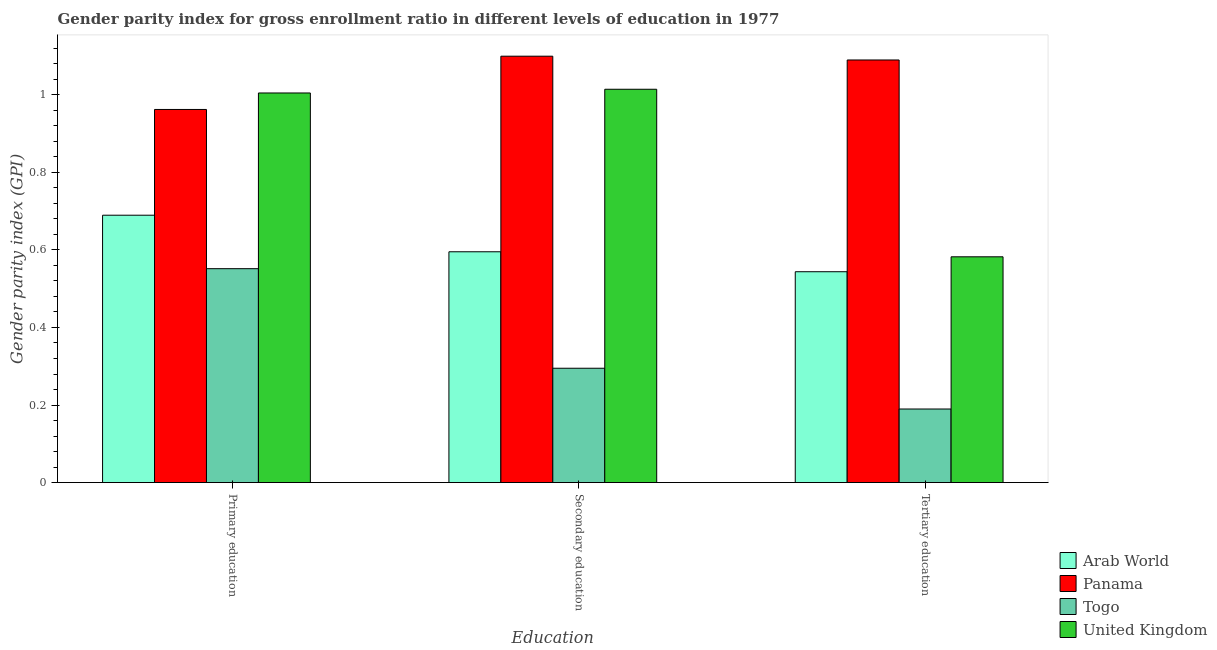Are the number of bars per tick equal to the number of legend labels?
Provide a short and direct response. Yes. How many bars are there on the 2nd tick from the right?
Ensure brevity in your answer.  4. What is the label of the 3rd group of bars from the left?
Keep it short and to the point. Tertiary education. What is the gender parity index in primary education in Arab World?
Make the answer very short. 0.69. Across all countries, what is the maximum gender parity index in tertiary education?
Make the answer very short. 1.09. Across all countries, what is the minimum gender parity index in secondary education?
Make the answer very short. 0.29. In which country was the gender parity index in primary education maximum?
Offer a very short reply. United Kingdom. In which country was the gender parity index in tertiary education minimum?
Provide a succinct answer. Togo. What is the total gender parity index in tertiary education in the graph?
Your response must be concise. 2.41. What is the difference between the gender parity index in secondary education in United Kingdom and that in Togo?
Your response must be concise. 0.72. What is the difference between the gender parity index in tertiary education in Panama and the gender parity index in primary education in Togo?
Offer a very short reply. 0.54. What is the average gender parity index in secondary education per country?
Keep it short and to the point. 0.75. What is the difference between the gender parity index in primary education and gender parity index in tertiary education in Togo?
Provide a succinct answer. 0.36. In how many countries, is the gender parity index in primary education greater than 1 ?
Make the answer very short. 1. What is the ratio of the gender parity index in secondary education in Panama to that in Togo?
Your answer should be very brief. 3.73. Is the gender parity index in primary education in United Kingdom less than that in Panama?
Keep it short and to the point. No. What is the difference between the highest and the second highest gender parity index in secondary education?
Give a very brief answer. 0.09. What is the difference between the highest and the lowest gender parity index in secondary education?
Your answer should be compact. 0.8. Is the sum of the gender parity index in secondary education in Togo and Arab World greater than the maximum gender parity index in primary education across all countries?
Provide a short and direct response. No. What does the 2nd bar from the left in Primary education represents?
Provide a succinct answer. Panama. What does the 3rd bar from the right in Secondary education represents?
Provide a succinct answer. Panama. Is it the case that in every country, the sum of the gender parity index in primary education and gender parity index in secondary education is greater than the gender parity index in tertiary education?
Your answer should be very brief. Yes. How many bars are there?
Your response must be concise. 12. Are all the bars in the graph horizontal?
Provide a succinct answer. No. Are the values on the major ticks of Y-axis written in scientific E-notation?
Give a very brief answer. No. Does the graph contain any zero values?
Your answer should be very brief. No. Does the graph contain grids?
Ensure brevity in your answer.  No. Where does the legend appear in the graph?
Your answer should be compact. Bottom right. How many legend labels are there?
Provide a short and direct response. 4. What is the title of the graph?
Give a very brief answer. Gender parity index for gross enrollment ratio in different levels of education in 1977. What is the label or title of the X-axis?
Offer a terse response. Education. What is the label or title of the Y-axis?
Keep it short and to the point. Gender parity index (GPI). What is the Gender parity index (GPI) in Arab World in Primary education?
Offer a very short reply. 0.69. What is the Gender parity index (GPI) in Panama in Primary education?
Offer a terse response. 0.96. What is the Gender parity index (GPI) in Togo in Primary education?
Provide a succinct answer. 0.55. What is the Gender parity index (GPI) of United Kingdom in Primary education?
Offer a very short reply. 1. What is the Gender parity index (GPI) in Arab World in Secondary education?
Your answer should be very brief. 0.6. What is the Gender parity index (GPI) in Panama in Secondary education?
Your response must be concise. 1.1. What is the Gender parity index (GPI) of Togo in Secondary education?
Offer a terse response. 0.29. What is the Gender parity index (GPI) in United Kingdom in Secondary education?
Your answer should be compact. 1.01. What is the Gender parity index (GPI) of Arab World in Tertiary education?
Provide a succinct answer. 0.54. What is the Gender parity index (GPI) in Panama in Tertiary education?
Your response must be concise. 1.09. What is the Gender parity index (GPI) of Togo in Tertiary education?
Make the answer very short. 0.19. What is the Gender parity index (GPI) in United Kingdom in Tertiary education?
Offer a terse response. 0.58. Across all Education, what is the maximum Gender parity index (GPI) of Arab World?
Provide a succinct answer. 0.69. Across all Education, what is the maximum Gender parity index (GPI) in Panama?
Provide a short and direct response. 1.1. Across all Education, what is the maximum Gender parity index (GPI) in Togo?
Ensure brevity in your answer.  0.55. Across all Education, what is the maximum Gender parity index (GPI) of United Kingdom?
Give a very brief answer. 1.01. Across all Education, what is the minimum Gender parity index (GPI) of Arab World?
Ensure brevity in your answer.  0.54. Across all Education, what is the minimum Gender parity index (GPI) of Panama?
Provide a short and direct response. 0.96. Across all Education, what is the minimum Gender parity index (GPI) of Togo?
Offer a very short reply. 0.19. Across all Education, what is the minimum Gender parity index (GPI) of United Kingdom?
Provide a succinct answer. 0.58. What is the total Gender parity index (GPI) in Arab World in the graph?
Ensure brevity in your answer.  1.83. What is the total Gender parity index (GPI) of Panama in the graph?
Ensure brevity in your answer.  3.15. What is the total Gender parity index (GPI) of Togo in the graph?
Offer a very short reply. 1.04. What is the total Gender parity index (GPI) of United Kingdom in the graph?
Your response must be concise. 2.6. What is the difference between the Gender parity index (GPI) in Arab World in Primary education and that in Secondary education?
Give a very brief answer. 0.09. What is the difference between the Gender parity index (GPI) of Panama in Primary education and that in Secondary education?
Keep it short and to the point. -0.14. What is the difference between the Gender parity index (GPI) in Togo in Primary education and that in Secondary education?
Your answer should be compact. 0.26. What is the difference between the Gender parity index (GPI) in United Kingdom in Primary education and that in Secondary education?
Give a very brief answer. -0.01. What is the difference between the Gender parity index (GPI) in Arab World in Primary education and that in Tertiary education?
Provide a short and direct response. 0.15. What is the difference between the Gender parity index (GPI) of Panama in Primary education and that in Tertiary education?
Provide a succinct answer. -0.13. What is the difference between the Gender parity index (GPI) in Togo in Primary education and that in Tertiary education?
Keep it short and to the point. 0.36. What is the difference between the Gender parity index (GPI) of United Kingdom in Primary education and that in Tertiary education?
Your answer should be very brief. 0.42. What is the difference between the Gender parity index (GPI) of Arab World in Secondary education and that in Tertiary education?
Your response must be concise. 0.05. What is the difference between the Gender parity index (GPI) in Panama in Secondary education and that in Tertiary education?
Ensure brevity in your answer.  0.01. What is the difference between the Gender parity index (GPI) of Togo in Secondary education and that in Tertiary education?
Ensure brevity in your answer.  0.11. What is the difference between the Gender parity index (GPI) in United Kingdom in Secondary education and that in Tertiary education?
Make the answer very short. 0.43. What is the difference between the Gender parity index (GPI) in Arab World in Primary education and the Gender parity index (GPI) in Panama in Secondary education?
Give a very brief answer. -0.41. What is the difference between the Gender parity index (GPI) in Arab World in Primary education and the Gender parity index (GPI) in Togo in Secondary education?
Offer a terse response. 0.39. What is the difference between the Gender parity index (GPI) of Arab World in Primary education and the Gender parity index (GPI) of United Kingdom in Secondary education?
Your response must be concise. -0.32. What is the difference between the Gender parity index (GPI) of Panama in Primary education and the Gender parity index (GPI) of Togo in Secondary education?
Provide a short and direct response. 0.67. What is the difference between the Gender parity index (GPI) of Panama in Primary education and the Gender parity index (GPI) of United Kingdom in Secondary education?
Offer a very short reply. -0.05. What is the difference between the Gender parity index (GPI) in Togo in Primary education and the Gender parity index (GPI) in United Kingdom in Secondary education?
Provide a short and direct response. -0.46. What is the difference between the Gender parity index (GPI) of Arab World in Primary education and the Gender parity index (GPI) of Panama in Tertiary education?
Offer a terse response. -0.4. What is the difference between the Gender parity index (GPI) of Arab World in Primary education and the Gender parity index (GPI) of Togo in Tertiary education?
Your response must be concise. 0.5. What is the difference between the Gender parity index (GPI) of Arab World in Primary education and the Gender parity index (GPI) of United Kingdom in Tertiary education?
Provide a succinct answer. 0.11. What is the difference between the Gender parity index (GPI) in Panama in Primary education and the Gender parity index (GPI) in Togo in Tertiary education?
Provide a short and direct response. 0.77. What is the difference between the Gender parity index (GPI) in Panama in Primary education and the Gender parity index (GPI) in United Kingdom in Tertiary education?
Your answer should be compact. 0.38. What is the difference between the Gender parity index (GPI) in Togo in Primary education and the Gender parity index (GPI) in United Kingdom in Tertiary education?
Provide a succinct answer. -0.03. What is the difference between the Gender parity index (GPI) of Arab World in Secondary education and the Gender parity index (GPI) of Panama in Tertiary education?
Make the answer very short. -0.49. What is the difference between the Gender parity index (GPI) of Arab World in Secondary education and the Gender parity index (GPI) of Togo in Tertiary education?
Keep it short and to the point. 0.41. What is the difference between the Gender parity index (GPI) of Arab World in Secondary education and the Gender parity index (GPI) of United Kingdom in Tertiary education?
Give a very brief answer. 0.01. What is the difference between the Gender parity index (GPI) in Panama in Secondary education and the Gender parity index (GPI) in Togo in Tertiary education?
Your answer should be very brief. 0.91. What is the difference between the Gender parity index (GPI) in Panama in Secondary education and the Gender parity index (GPI) in United Kingdom in Tertiary education?
Your answer should be very brief. 0.52. What is the difference between the Gender parity index (GPI) of Togo in Secondary education and the Gender parity index (GPI) of United Kingdom in Tertiary education?
Your answer should be compact. -0.29. What is the average Gender parity index (GPI) of Arab World per Education?
Provide a short and direct response. 0.61. What is the average Gender parity index (GPI) in Panama per Education?
Provide a succinct answer. 1.05. What is the average Gender parity index (GPI) in Togo per Education?
Make the answer very short. 0.35. What is the average Gender parity index (GPI) of United Kingdom per Education?
Keep it short and to the point. 0.87. What is the difference between the Gender parity index (GPI) in Arab World and Gender parity index (GPI) in Panama in Primary education?
Ensure brevity in your answer.  -0.27. What is the difference between the Gender parity index (GPI) in Arab World and Gender parity index (GPI) in Togo in Primary education?
Provide a short and direct response. 0.14. What is the difference between the Gender parity index (GPI) of Arab World and Gender parity index (GPI) of United Kingdom in Primary education?
Your answer should be very brief. -0.32. What is the difference between the Gender parity index (GPI) of Panama and Gender parity index (GPI) of Togo in Primary education?
Give a very brief answer. 0.41. What is the difference between the Gender parity index (GPI) in Panama and Gender parity index (GPI) in United Kingdom in Primary education?
Offer a very short reply. -0.04. What is the difference between the Gender parity index (GPI) of Togo and Gender parity index (GPI) of United Kingdom in Primary education?
Provide a short and direct response. -0.45. What is the difference between the Gender parity index (GPI) of Arab World and Gender parity index (GPI) of Panama in Secondary education?
Offer a very short reply. -0.5. What is the difference between the Gender parity index (GPI) in Arab World and Gender parity index (GPI) in Togo in Secondary education?
Provide a succinct answer. 0.3. What is the difference between the Gender parity index (GPI) of Arab World and Gender parity index (GPI) of United Kingdom in Secondary education?
Your answer should be very brief. -0.42. What is the difference between the Gender parity index (GPI) of Panama and Gender parity index (GPI) of Togo in Secondary education?
Offer a very short reply. 0.8. What is the difference between the Gender parity index (GPI) in Panama and Gender parity index (GPI) in United Kingdom in Secondary education?
Offer a terse response. 0.09. What is the difference between the Gender parity index (GPI) of Togo and Gender parity index (GPI) of United Kingdom in Secondary education?
Your answer should be compact. -0.72. What is the difference between the Gender parity index (GPI) of Arab World and Gender parity index (GPI) of Panama in Tertiary education?
Your response must be concise. -0.55. What is the difference between the Gender parity index (GPI) of Arab World and Gender parity index (GPI) of Togo in Tertiary education?
Your answer should be compact. 0.35. What is the difference between the Gender parity index (GPI) in Arab World and Gender parity index (GPI) in United Kingdom in Tertiary education?
Offer a very short reply. -0.04. What is the difference between the Gender parity index (GPI) in Panama and Gender parity index (GPI) in Togo in Tertiary education?
Ensure brevity in your answer.  0.9. What is the difference between the Gender parity index (GPI) of Panama and Gender parity index (GPI) of United Kingdom in Tertiary education?
Your answer should be compact. 0.51. What is the difference between the Gender parity index (GPI) of Togo and Gender parity index (GPI) of United Kingdom in Tertiary education?
Offer a very short reply. -0.39. What is the ratio of the Gender parity index (GPI) in Arab World in Primary education to that in Secondary education?
Your answer should be very brief. 1.16. What is the ratio of the Gender parity index (GPI) in Panama in Primary education to that in Secondary education?
Your answer should be compact. 0.88. What is the ratio of the Gender parity index (GPI) of Togo in Primary education to that in Secondary education?
Offer a terse response. 1.87. What is the ratio of the Gender parity index (GPI) of United Kingdom in Primary education to that in Secondary education?
Make the answer very short. 0.99. What is the ratio of the Gender parity index (GPI) in Arab World in Primary education to that in Tertiary education?
Ensure brevity in your answer.  1.27. What is the ratio of the Gender parity index (GPI) in Panama in Primary education to that in Tertiary education?
Provide a succinct answer. 0.88. What is the ratio of the Gender parity index (GPI) in Togo in Primary education to that in Tertiary education?
Your answer should be very brief. 2.91. What is the ratio of the Gender parity index (GPI) of United Kingdom in Primary education to that in Tertiary education?
Your response must be concise. 1.73. What is the ratio of the Gender parity index (GPI) in Arab World in Secondary education to that in Tertiary education?
Offer a very short reply. 1.09. What is the ratio of the Gender parity index (GPI) in Panama in Secondary education to that in Tertiary education?
Offer a very short reply. 1.01. What is the ratio of the Gender parity index (GPI) of Togo in Secondary education to that in Tertiary education?
Provide a short and direct response. 1.55. What is the ratio of the Gender parity index (GPI) in United Kingdom in Secondary education to that in Tertiary education?
Give a very brief answer. 1.74. What is the difference between the highest and the second highest Gender parity index (GPI) of Arab World?
Provide a succinct answer. 0.09. What is the difference between the highest and the second highest Gender parity index (GPI) in Panama?
Your answer should be compact. 0.01. What is the difference between the highest and the second highest Gender parity index (GPI) of Togo?
Ensure brevity in your answer.  0.26. What is the difference between the highest and the second highest Gender parity index (GPI) in United Kingdom?
Give a very brief answer. 0.01. What is the difference between the highest and the lowest Gender parity index (GPI) of Arab World?
Provide a short and direct response. 0.15. What is the difference between the highest and the lowest Gender parity index (GPI) in Panama?
Provide a short and direct response. 0.14. What is the difference between the highest and the lowest Gender parity index (GPI) in Togo?
Offer a terse response. 0.36. What is the difference between the highest and the lowest Gender parity index (GPI) in United Kingdom?
Your answer should be compact. 0.43. 